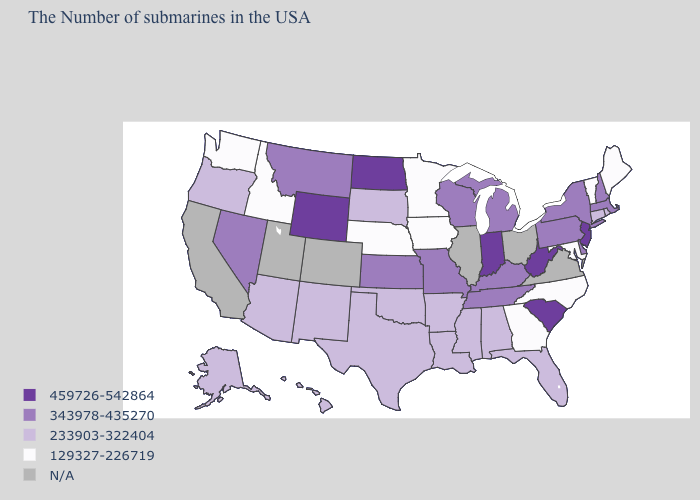What is the highest value in the USA?
Quick response, please. 459726-542864. Name the states that have a value in the range 343978-435270?
Answer briefly. Massachusetts, New Hampshire, New York, Delaware, Pennsylvania, Michigan, Kentucky, Tennessee, Wisconsin, Missouri, Kansas, Montana, Nevada. What is the value of South Carolina?
Be succinct. 459726-542864. Name the states that have a value in the range 129327-226719?
Quick response, please. Maine, Vermont, Maryland, North Carolina, Georgia, Minnesota, Iowa, Nebraska, Idaho, Washington. Does Indiana have the highest value in the MidWest?
Short answer required. Yes. Among the states that border Illinois , which have the lowest value?
Be succinct. Iowa. How many symbols are there in the legend?
Short answer required. 5. What is the value of Wyoming?
Write a very short answer. 459726-542864. What is the value of Idaho?
Give a very brief answer. 129327-226719. What is the lowest value in the USA?
Quick response, please. 129327-226719. Name the states that have a value in the range 343978-435270?
Write a very short answer. Massachusetts, New Hampshire, New York, Delaware, Pennsylvania, Michigan, Kentucky, Tennessee, Wisconsin, Missouri, Kansas, Montana, Nevada. Does South Carolina have the highest value in the USA?
Answer briefly. Yes. Among the states that border Kansas , does Missouri have the lowest value?
Write a very short answer. No. 